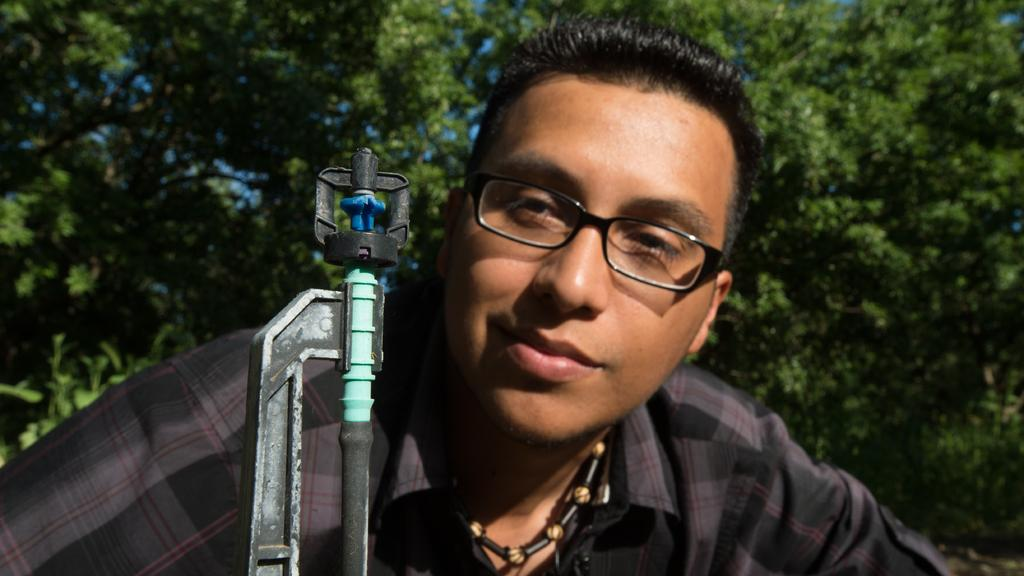Who is present in the image? There is a person in the image. What can be observed about the person's appearance? The person is wearing spectacles. What object is present in the image that is typically used for cutting or shaping materials? There is a hacksaw frame with a blade in the image. What natural element can be seen in the background of the image? There is a tree visible in the background of the image. How many babies are present in the image? There are no babies present in the image. What type of harmony is being played by the person in the image? There is no indication of music or harmony in the image. 